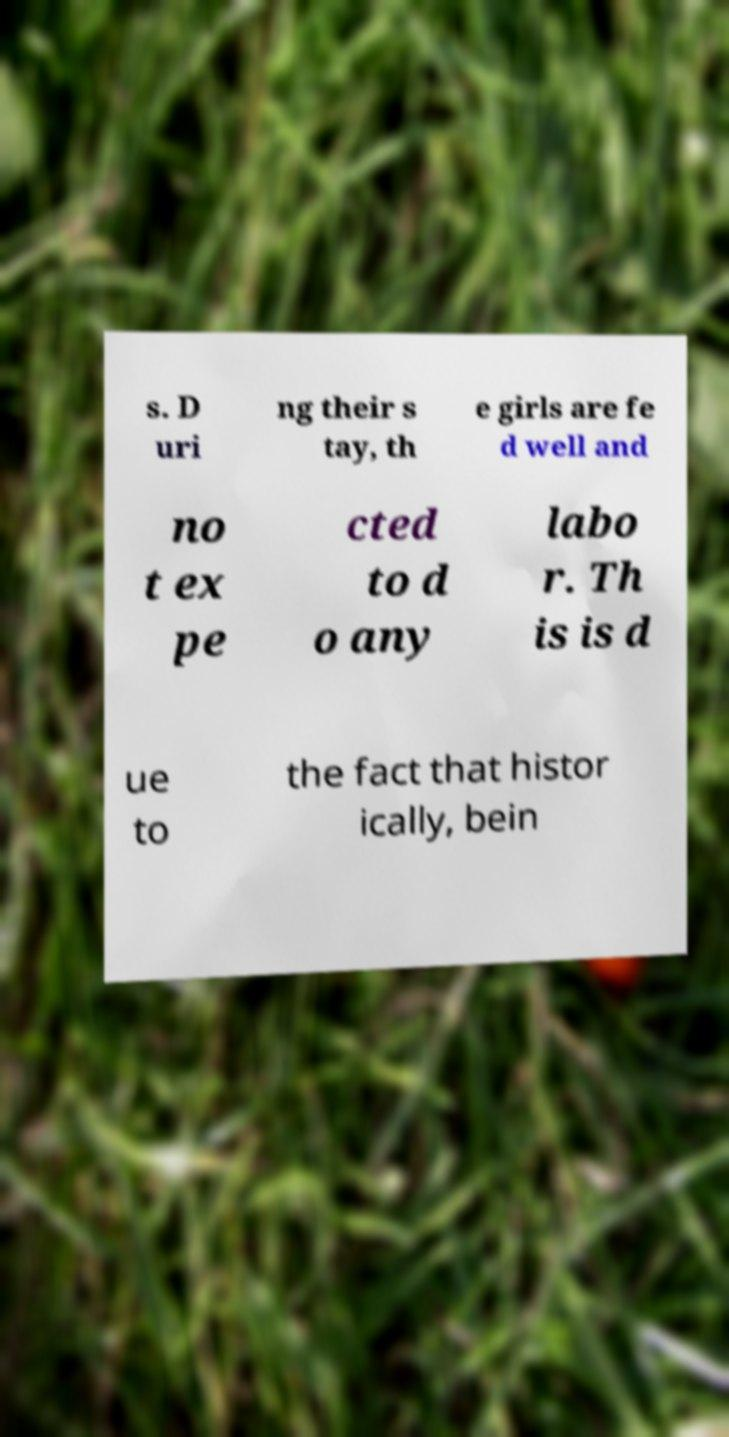Could you assist in decoding the text presented in this image and type it out clearly? s. D uri ng their s tay, th e girls are fe d well and no t ex pe cted to d o any labo r. Th is is d ue to the fact that histor ically, bein 